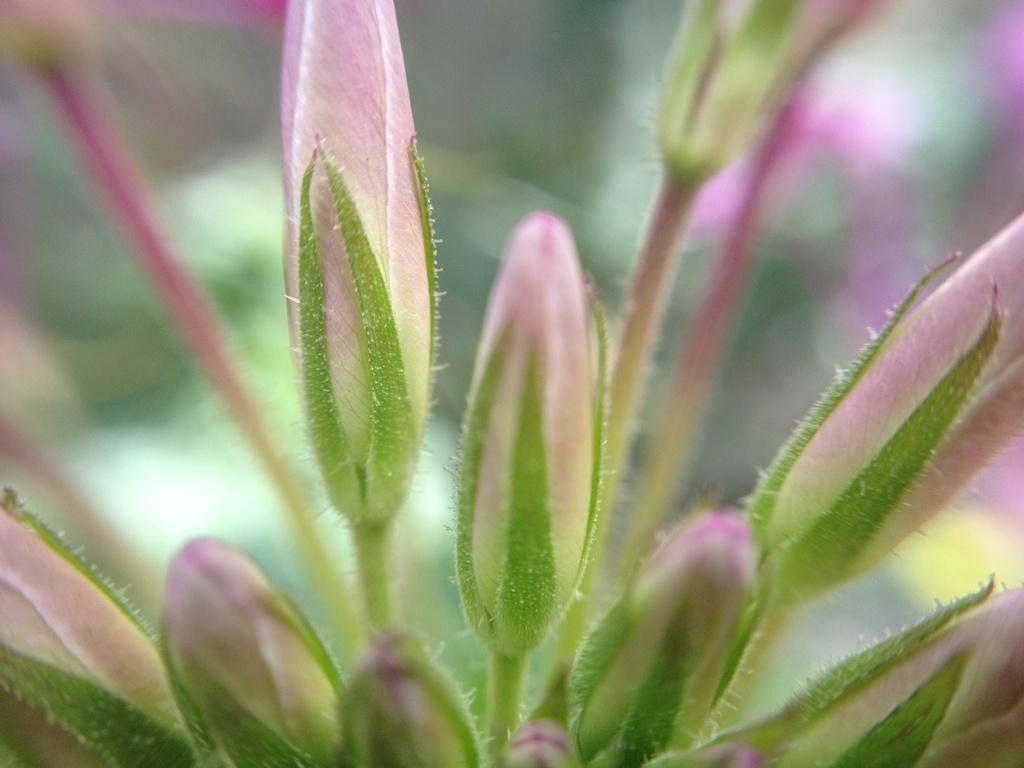What is present in the image? There are buds in the image. Can you describe the background of the image? The background of the image is blurry. How many lizards can be seen on the buds in the image? There are no lizards present in the image; it only features buds. What scale is used to measure the size of the buds in the image? There is no scale present in the image, and the size of the buds cannot be measured from the image alone. 